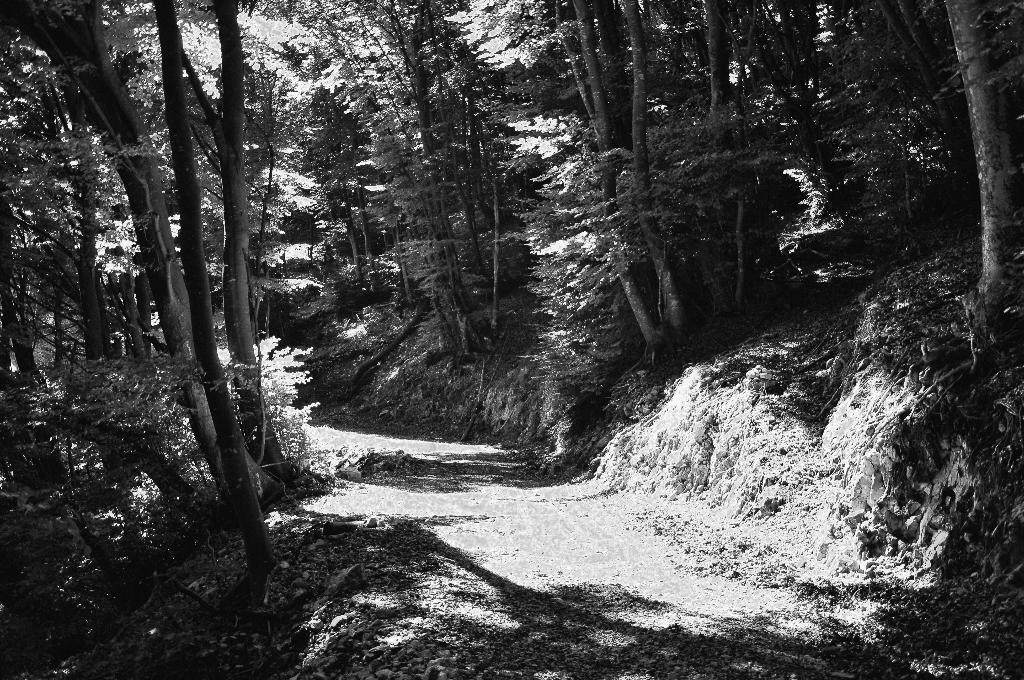What is the color scheme of the image? The picture is black and white. What type of natural elements can be seen in the image? There are trees in the image. Is there any man-made structure visible in the image? Yes, there is a path in the image. Can you see any fangs in the image? There are no fangs present in the image. How many memories can be seen in the image? Memories are not visible in the image, as they are intangible concepts and not physical objects. 